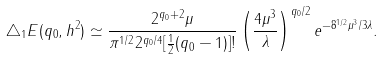<formula> <loc_0><loc_0><loc_500><loc_500>\triangle _ { 1 } E ( q _ { 0 } , h ^ { 2 } ) \simeq \frac { 2 ^ { q _ { 0 } + 2 } \mu } { { \pi } ^ { 1 / 2 } 2 ^ { q _ { 0 } / 4 } [ \frac { 1 } { 2 } ( q _ { 0 } - 1 ) ] ! } \left ( \frac { 4 \mu ^ { 3 } } { \lambda } \right ) ^ { q _ { 0 } / 2 } e ^ { - 8 ^ { 1 / 2 } \mu ^ { 3 } / 3 \lambda } .</formula> 